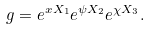<formula> <loc_0><loc_0><loc_500><loc_500>g = e ^ { x X _ { 1 } } e ^ { \psi X _ { 2 } } e ^ { \chi X _ { 3 } } .</formula> 